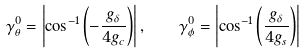Convert formula to latex. <formula><loc_0><loc_0><loc_500><loc_500>\gamma _ { \theta } ^ { 0 } = \left | \cos ^ { - 1 } \left ( - \frac { g _ { \delta } } { 4 g _ { c } } \right ) \right | , \quad \gamma _ { \phi } ^ { 0 } = \left | \cos ^ { - 1 } \left ( \frac { g _ { \delta } } { 4 g _ { s } } \right ) \right |</formula> 